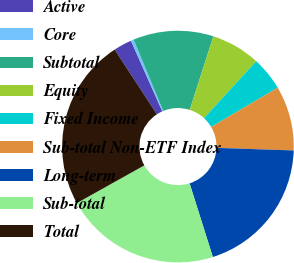Convert chart to OTSL. <chart><loc_0><loc_0><loc_500><loc_500><pie_chart><fcel>Active<fcel>Core<fcel>Subtotal<fcel>Equity<fcel>Fixed Income<fcel>Sub-total Non-ETF Index<fcel>Long-term<fcel>Sub-total<fcel>Total<nl><fcel>2.55%<fcel>0.4%<fcel>11.2%<fcel>6.86%<fcel>4.71%<fcel>9.02%<fcel>19.6%<fcel>21.76%<fcel>23.91%<nl></chart> 